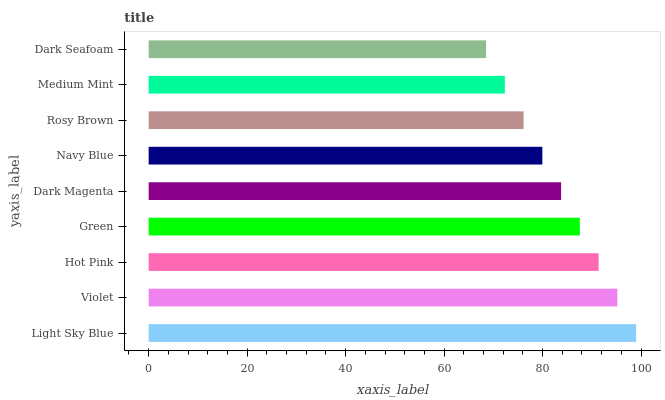Is Dark Seafoam the minimum?
Answer yes or no. Yes. Is Light Sky Blue the maximum?
Answer yes or no. Yes. Is Violet the minimum?
Answer yes or no. No. Is Violet the maximum?
Answer yes or no. No. Is Light Sky Blue greater than Violet?
Answer yes or no. Yes. Is Violet less than Light Sky Blue?
Answer yes or no. Yes. Is Violet greater than Light Sky Blue?
Answer yes or no. No. Is Light Sky Blue less than Violet?
Answer yes or no. No. Is Dark Magenta the high median?
Answer yes or no. Yes. Is Dark Magenta the low median?
Answer yes or no. Yes. Is Rosy Brown the high median?
Answer yes or no. No. Is Green the low median?
Answer yes or no. No. 